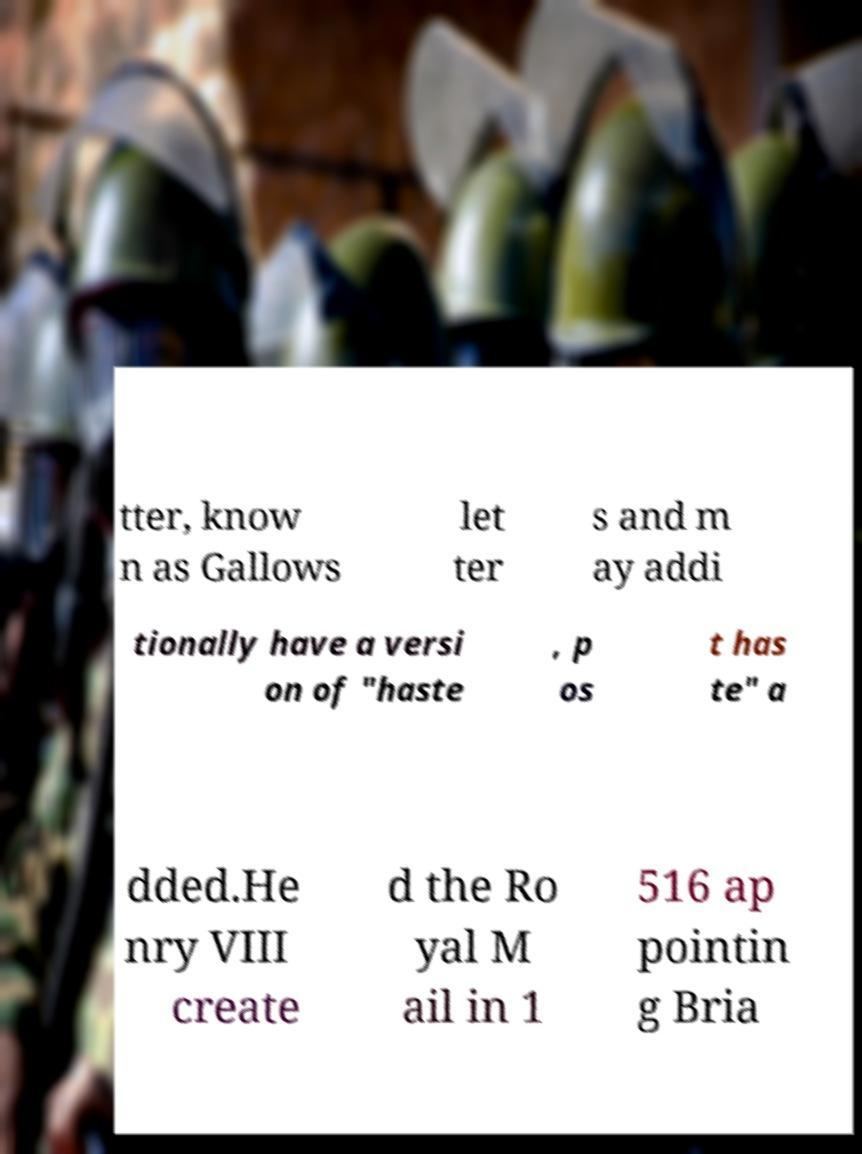I need the written content from this picture converted into text. Can you do that? tter, know n as Gallows let ter s and m ay addi tionally have a versi on of "haste , p os t has te" a dded.He nry VIII create d the Ro yal M ail in 1 516 ap pointin g Bria 